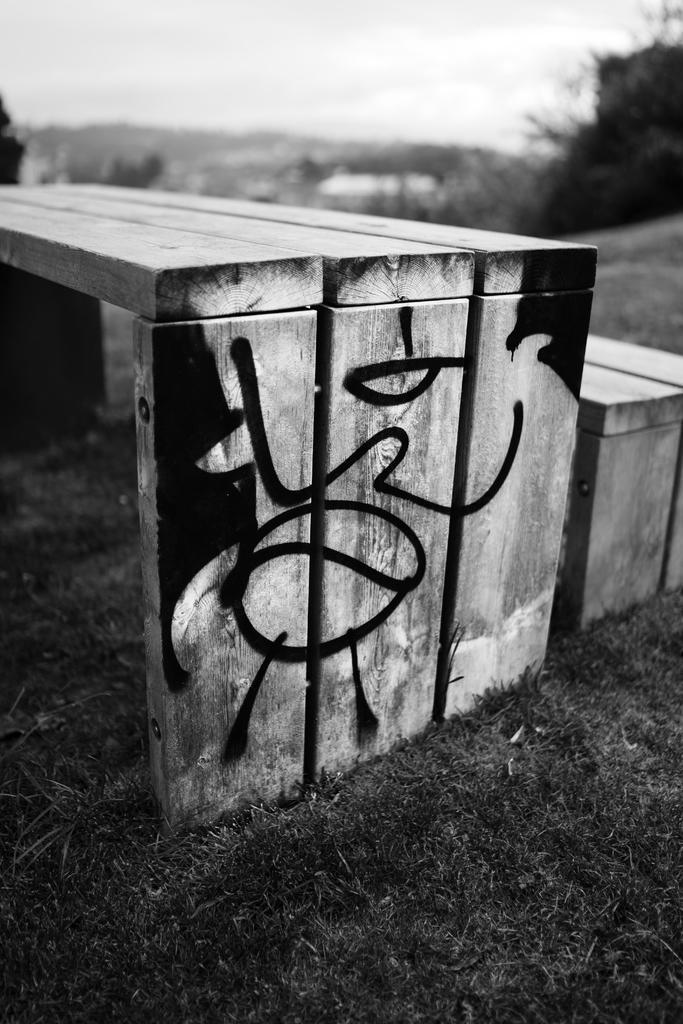How would you summarize this image in a sentence or two? This is a black and white picture. Background portion of the picture is blurry and we can see the sky and trees. We can see wooden benches and we can see black painting on it. At the bottom we can see the grass. 